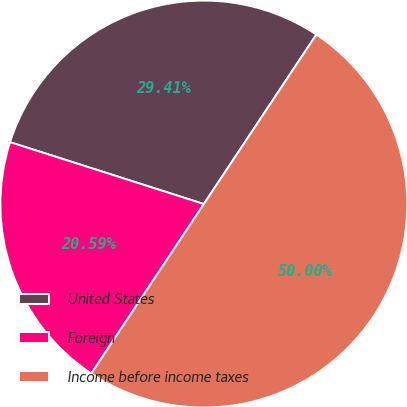Convert chart to OTSL. <chart><loc_0><loc_0><loc_500><loc_500><pie_chart><fcel>United States<fcel>Foreign<fcel>Income before income taxes<nl><fcel>29.41%<fcel>20.59%<fcel>50.0%<nl></chart> 